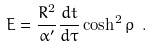<formula> <loc_0><loc_0><loc_500><loc_500>E = { \frac { R ^ { 2 } } { \alpha ^ { \prime } } } { \frac { d t } { d \tau } } \cosh ^ { 2 } \rho \ .</formula> 